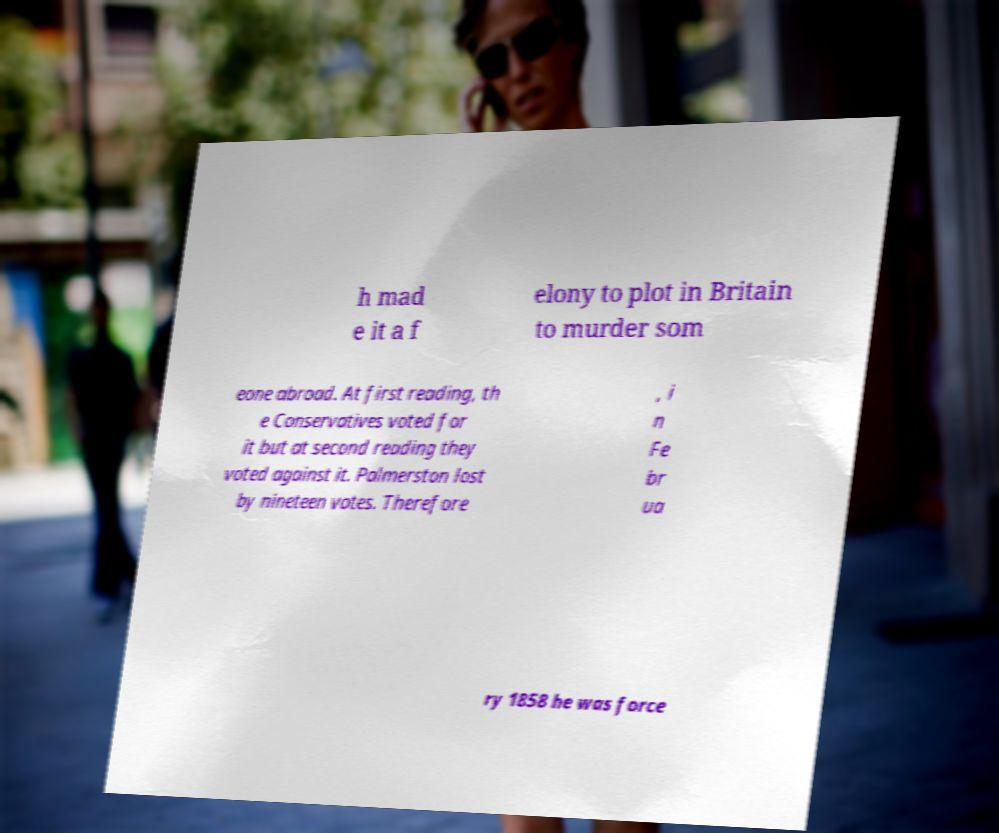Please read and relay the text visible in this image. What does it say? h mad e it a f elony to plot in Britain to murder som eone abroad. At first reading, th e Conservatives voted for it but at second reading they voted against it. Palmerston lost by nineteen votes. Therefore , i n Fe br ua ry 1858 he was force 